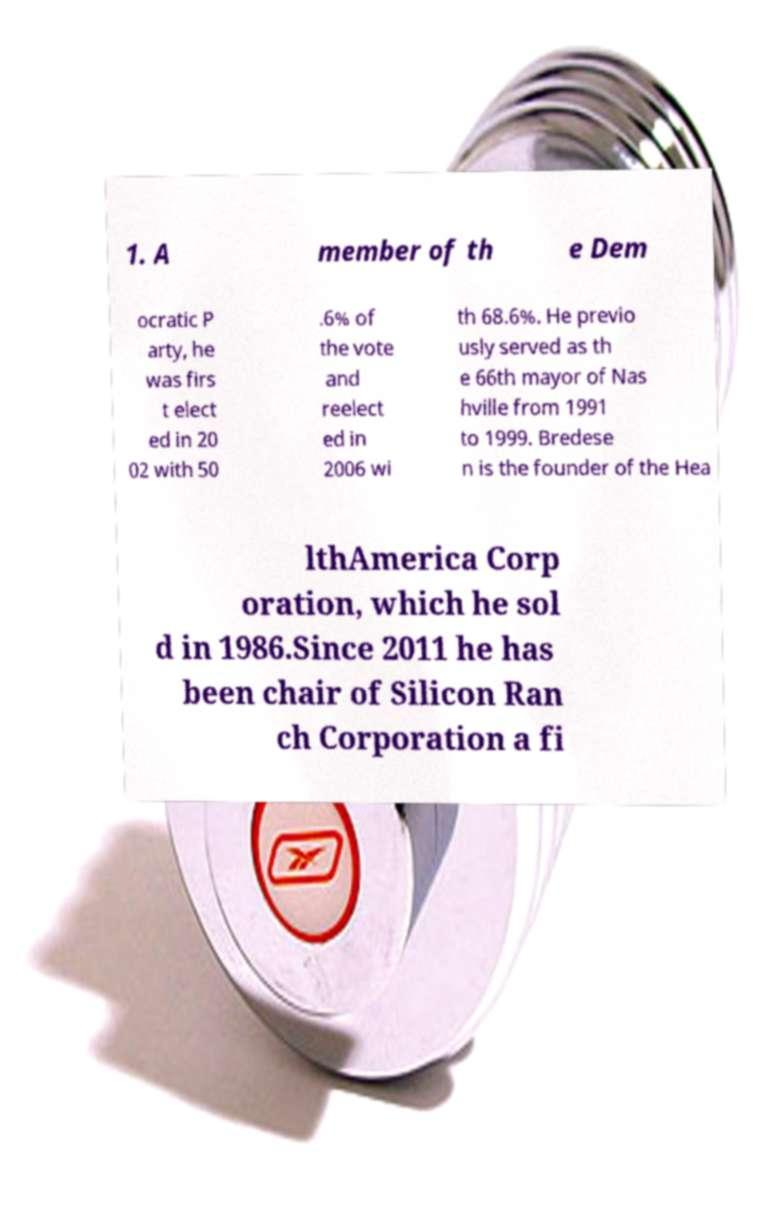Could you extract and type out the text from this image? 1. A member of th e Dem ocratic P arty, he was firs t elect ed in 20 02 with 50 .6% of the vote and reelect ed in 2006 wi th 68.6%. He previo usly served as th e 66th mayor of Nas hville from 1991 to 1999. Bredese n is the founder of the Hea lthAmerica Corp oration, which he sol d in 1986.Since 2011 he has been chair of Silicon Ran ch Corporation a fi 